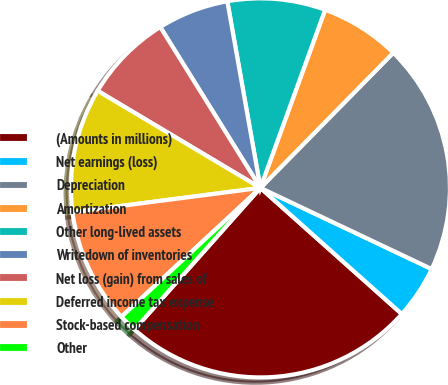Convert chart. <chart><loc_0><loc_0><loc_500><loc_500><pie_chart><fcel>(Amounts in millions)<fcel>Net earnings (loss)<fcel>Depreciation<fcel>Amortization<fcel>Other long-lived assets<fcel>Writedown of inventories<fcel>Net loss (gain) from sales of<fcel>Deferred income tax expense<fcel>Stock-based compensation<fcel>Other<nl><fcel>24.98%<fcel>4.55%<fcel>19.68%<fcel>6.82%<fcel>8.34%<fcel>6.07%<fcel>7.58%<fcel>10.61%<fcel>9.85%<fcel>1.53%<nl></chart> 